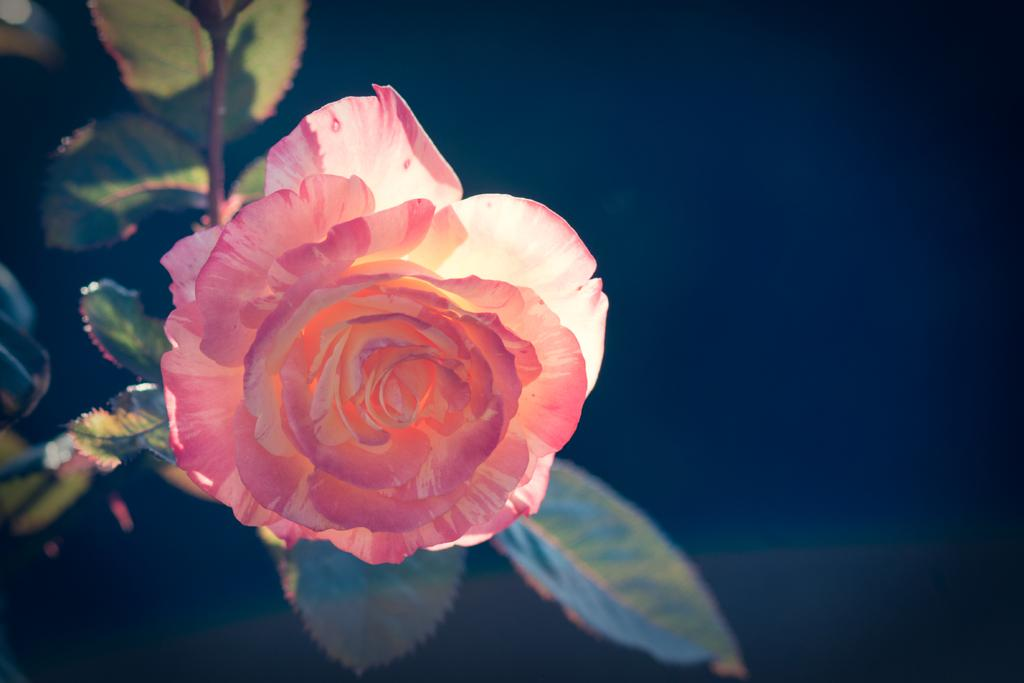What is the main subject of the image? The main subject of the image is a flower on a plant. Where is the flower located in relation to the image? The flower is in the center of the image. What type of secretary can be seen working in the image? There is no secretary present in the image; it features a flower on a plant. What type of amusement is depicted in the image? There is no amusement depicted in the image; it features a flower on a plant. 